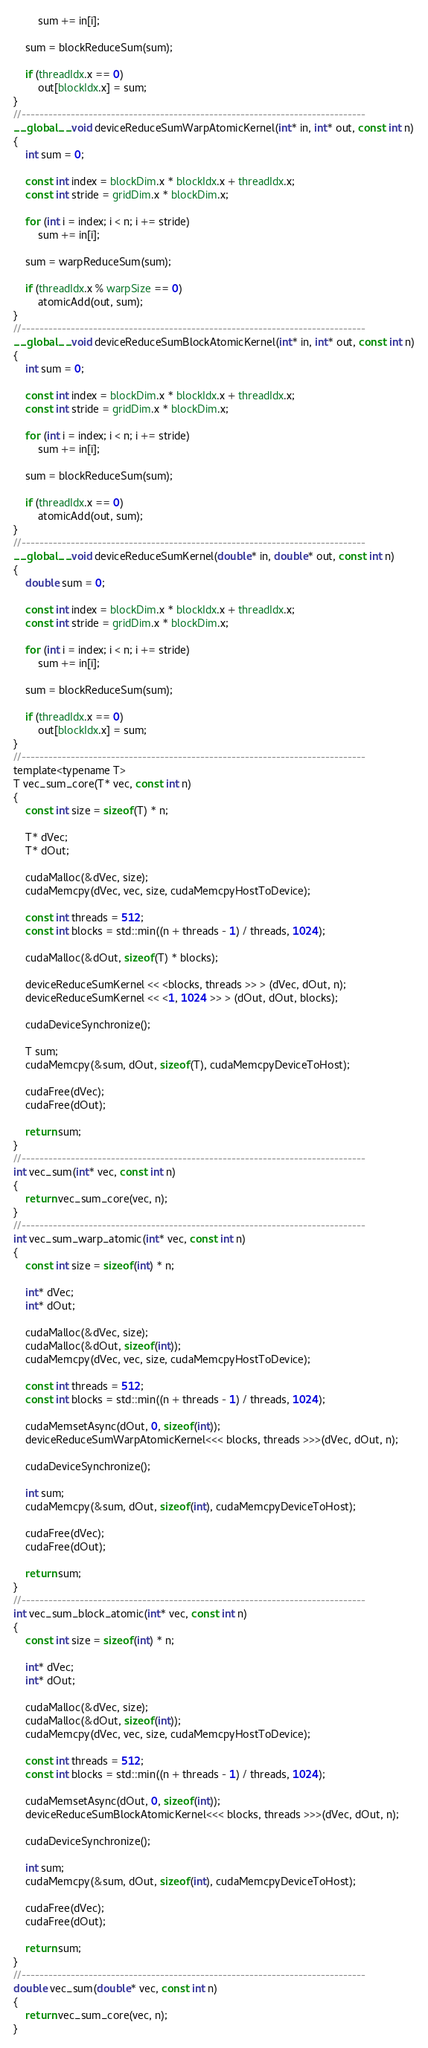<code> <loc_0><loc_0><loc_500><loc_500><_Cuda_>        sum += in[i];

    sum = blockReduceSum(sum);

    if (threadIdx.x == 0)
        out[blockIdx.x] = sum;
}
//-----------------------------------------------------------------------------
__global__ void deviceReduceSumWarpAtomicKernel(int* in, int* out, const int n)
{
    int sum = 0;

    const int index = blockDim.x * blockIdx.x + threadIdx.x;
    const int stride = gridDim.x * blockDim.x;

    for (int i = index; i < n; i += stride)
        sum += in[i];

    sum = warpReduceSum(sum);

    if (threadIdx.x % warpSize == 0)
        atomicAdd(out, sum);
}
//-----------------------------------------------------------------------------
__global__ void deviceReduceSumBlockAtomicKernel(int* in, int* out, const int n)
{
    int sum = 0;

    const int index = blockDim.x * blockIdx.x + threadIdx.x;
    const int stride = gridDim.x * blockDim.x;

    for (int i = index; i < n; i += stride)
        sum += in[i];

    sum = blockReduceSum(sum);

    if (threadIdx.x == 0)
        atomicAdd(out, sum);
}
//-----------------------------------------------------------------------------
__global__ void deviceReduceSumKernel(double* in, double* out, const int n)
{
    double sum = 0;

    const int index = blockDim.x * blockIdx.x + threadIdx.x;
    const int stride = gridDim.x * blockDim.x;

    for (int i = index; i < n; i += stride)
        sum += in[i];

    sum = blockReduceSum(sum);

    if (threadIdx.x == 0)
        out[blockIdx.x] = sum;
}
//-----------------------------------------------------------------------------
template<typename T>
T vec_sum_core(T* vec, const int n)
{
    const int size = sizeof(T) * n;

    T* dVec;
    T* dOut;

    cudaMalloc(&dVec, size);
    cudaMemcpy(dVec, vec, size, cudaMemcpyHostToDevice);

    const int threads = 512;
    const int blocks = std::min((n + threads - 1) / threads, 1024);

    cudaMalloc(&dOut, sizeof(T) * blocks);

    deviceReduceSumKernel << <blocks, threads >> > (dVec, dOut, n);
    deviceReduceSumKernel << <1, 1024 >> > (dOut, dOut, blocks);

    cudaDeviceSynchronize();

    T sum;
    cudaMemcpy(&sum, dOut, sizeof(T), cudaMemcpyDeviceToHost);

    cudaFree(dVec);
    cudaFree(dOut);

    return sum;
}
//-----------------------------------------------------------------------------
int vec_sum(int* vec, const int n)
{
    return vec_sum_core(vec, n);
}
//-----------------------------------------------------------------------------
int vec_sum_warp_atomic(int* vec, const int n)
{
    const int size = sizeof(int) * n;

    int* dVec;
    int* dOut;

    cudaMalloc(&dVec, size);
    cudaMalloc(&dOut, sizeof(int));
    cudaMemcpy(dVec, vec, size, cudaMemcpyHostToDevice);

    const int threads = 512;
    const int blocks = std::min((n + threads - 1) / threads, 1024);

    cudaMemsetAsync(dOut, 0, sizeof(int));
    deviceReduceSumWarpAtomicKernel<<< blocks, threads >>>(dVec, dOut, n);
    
    cudaDeviceSynchronize();

    int sum;
    cudaMemcpy(&sum, dOut, sizeof(int), cudaMemcpyDeviceToHost);

    cudaFree(dVec);
    cudaFree(dOut);

    return sum;
}
//-----------------------------------------------------------------------------
int vec_sum_block_atomic(int* vec, const int n)
{
    const int size = sizeof(int) * n;

    int* dVec;
    int* dOut;

    cudaMalloc(&dVec, size);
    cudaMalloc(&dOut, sizeof(int));
    cudaMemcpy(dVec, vec, size, cudaMemcpyHostToDevice);

    const int threads = 512;
    const int blocks = std::min((n + threads - 1) / threads, 1024);

    cudaMemsetAsync(dOut, 0, sizeof(int));
    deviceReduceSumBlockAtomicKernel<<< blocks, threads >>>(dVec, dOut, n);

    cudaDeviceSynchronize();

    int sum;
    cudaMemcpy(&sum, dOut, sizeof(int), cudaMemcpyDeviceToHost);

    cudaFree(dVec);
    cudaFree(dOut);

    return sum;
}
//-----------------------------------------------------------------------------
double vec_sum(double* vec, const int n)
{
    return vec_sum_core(vec, n);
}
</code> 